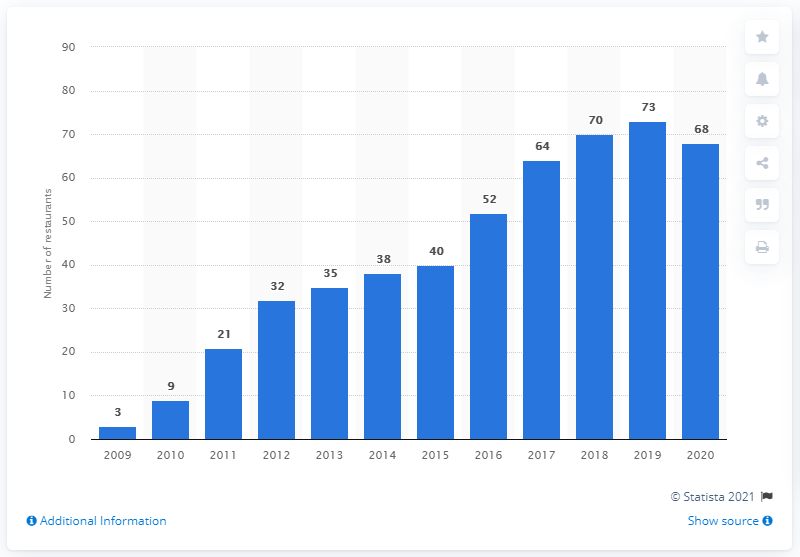Highlight a few significant elements in this photo. As of the end of 2020, there were 68 Starbucks restaurants operating in Poland. 